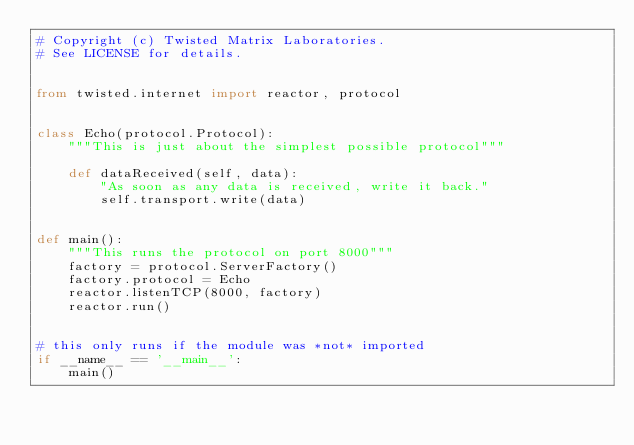Convert code to text. <code><loc_0><loc_0><loc_500><loc_500><_Python_># Copyright (c) Twisted Matrix Laboratories.
# See LICENSE for details.


from twisted.internet import reactor, protocol


class Echo(protocol.Protocol):
    """This is just about the simplest possible protocol"""

    def dataReceived(self, data):
        "As soon as any data is received, write it back."
        self.transport.write(data)


def main():
    """This runs the protocol on port 8000"""
    factory = protocol.ServerFactory()
    factory.protocol = Echo
    reactor.listenTCP(8000, factory)
    reactor.run()


# this only runs if the module was *not* imported
if __name__ == '__main__':
    main()
</code> 